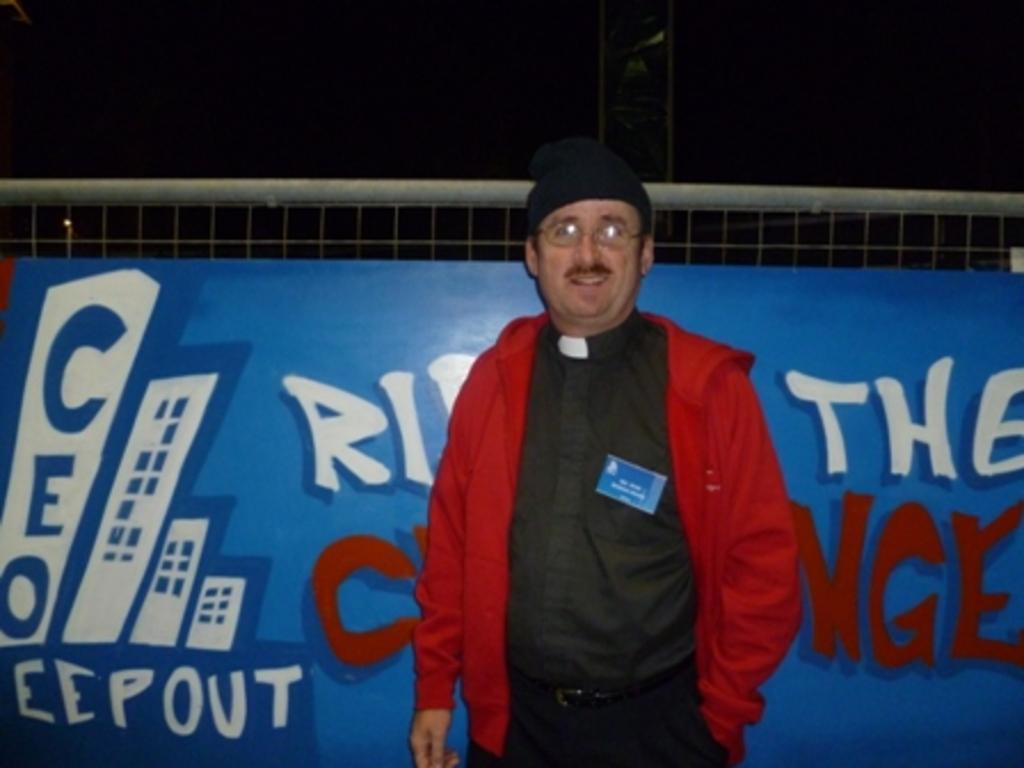Please provide a concise description of this image. In the image we can see there is a person standing and he is wearing red colour jacket, spectacles and black colour cap. Behind there is a banner and there is a net. The sky is dark. 